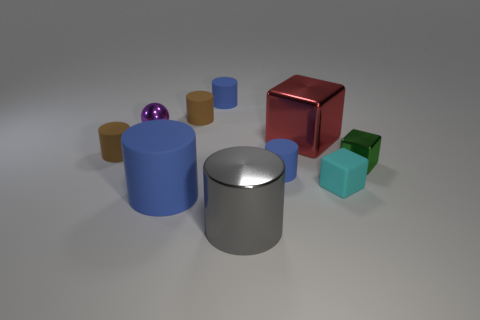Subtract all tiny brown cylinders. How many cylinders are left? 4 Subtract all gray balls. How many blue cylinders are left? 3 Subtract 1 blocks. How many blocks are left? 2 Subtract all brown cylinders. How many cylinders are left? 4 Subtract all cylinders. How many objects are left? 4 Subtract all gray cylinders. Subtract all gray blocks. How many cylinders are left? 5 Subtract all big blue objects. Subtract all metallic things. How many objects are left? 5 Add 6 large cylinders. How many large cylinders are left? 8 Add 6 rubber spheres. How many rubber spheres exist? 6 Subtract 0 blue blocks. How many objects are left? 10 